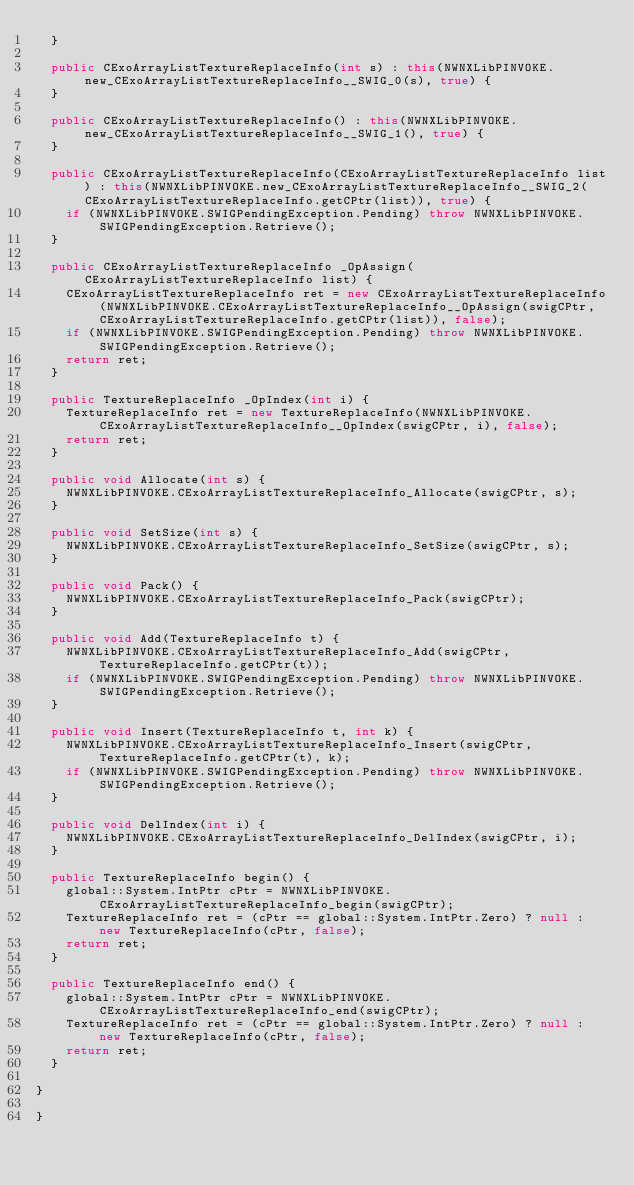Convert code to text. <code><loc_0><loc_0><loc_500><loc_500><_C#_>  }

  public CExoArrayListTextureReplaceInfo(int s) : this(NWNXLibPINVOKE.new_CExoArrayListTextureReplaceInfo__SWIG_0(s), true) {
  }

  public CExoArrayListTextureReplaceInfo() : this(NWNXLibPINVOKE.new_CExoArrayListTextureReplaceInfo__SWIG_1(), true) {
  }

  public CExoArrayListTextureReplaceInfo(CExoArrayListTextureReplaceInfo list) : this(NWNXLibPINVOKE.new_CExoArrayListTextureReplaceInfo__SWIG_2(CExoArrayListTextureReplaceInfo.getCPtr(list)), true) {
    if (NWNXLibPINVOKE.SWIGPendingException.Pending) throw NWNXLibPINVOKE.SWIGPendingException.Retrieve();
  }

  public CExoArrayListTextureReplaceInfo _OpAssign(CExoArrayListTextureReplaceInfo list) {
    CExoArrayListTextureReplaceInfo ret = new CExoArrayListTextureReplaceInfo(NWNXLibPINVOKE.CExoArrayListTextureReplaceInfo__OpAssign(swigCPtr, CExoArrayListTextureReplaceInfo.getCPtr(list)), false);
    if (NWNXLibPINVOKE.SWIGPendingException.Pending) throw NWNXLibPINVOKE.SWIGPendingException.Retrieve();
    return ret;
  }

  public TextureReplaceInfo _OpIndex(int i) {
    TextureReplaceInfo ret = new TextureReplaceInfo(NWNXLibPINVOKE.CExoArrayListTextureReplaceInfo__OpIndex(swigCPtr, i), false);
    return ret;
  }

  public void Allocate(int s) {
    NWNXLibPINVOKE.CExoArrayListTextureReplaceInfo_Allocate(swigCPtr, s);
  }

  public void SetSize(int s) {
    NWNXLibPINVOKE.CExoArrayListTextureReplaceInfo_SetSize(swigCPtr, s);
  }

  public void Pack() {
    NWNXLibPINVOKE.CExoArrayListTextureReplaceInfo_Pack(swigCPtr);
  }

  public void Add(TextureReplaceInfo t) {
    NWNXLibPINVOKE.CExoArrayListTextureReplaceInfo_Add(swigCPtr, TextureReplaceInfo.getCPtr(t));
    if (NWNXLibPINVOKE.SWIGPendingException.Pending) throw NWNXLibPINVOKE.SWIGPendingException.Retrieve();
  }

  public void Insert(TextureReplaceInfo t, int k) {
    NWNXLibPINVOKE.CExoArrayListTextureReplaceInfo_Insert(swigCPtr, TextureReplaceInfo.getCPtr(t), k);
    if (NWNXLibPINVOKE.SWIGPendingException.Pending) throw NWNXLibPINVOKE.SWIGPendingException.Retrieve();
  }

  public void DelIndex(int i) {
    NWNXLibPINVOKE.CExoArrayListTextureReplaceInfo_DelIndex(swigCPtr, i);
  }

  public TextureReplaceInfo begin() {
    global::System.IntPtr cPtr = NWNXLibPINVOKE.CExoArrayListTextureReplaceInfo_begin(swigCPtr);
    TextureReplaceInfo ret = (cPtr == global::System.IntPtr.Zero) ? null : new TextureReplaceInfo(cPtr, false);
    return ret;
  }

  public TextureReplaceInfo end() {
    global::System.IntPtr cPtr = NWNXLibPINVOKE.CExoArrayListTextureReplaceInfo_end(swigCPtr);
    TextureReplaceInfo ret = (cPtr == global::System.IntPtr.Zero) ? null : new TextureReplaceInfo(cPtr, false);
    return ret;
  }

}

}
</code> 